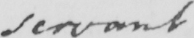What does this handwritten line say? servant 